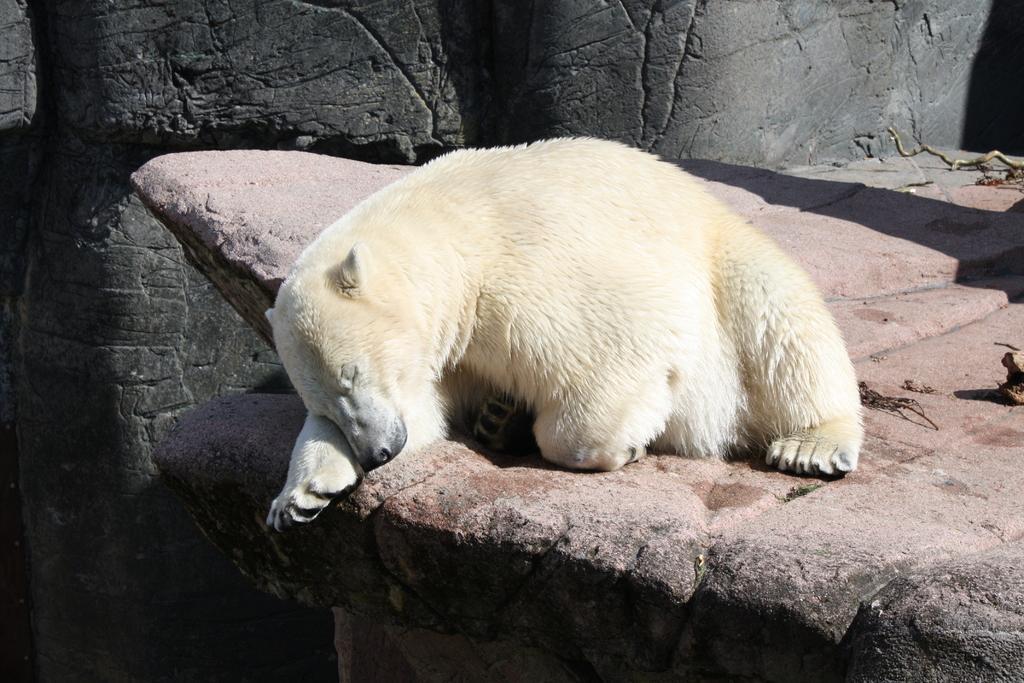How would you summarize this image in a sentence or two? In this picture we can see polar bear and some objects on a rock and in the background we can see rocks. 